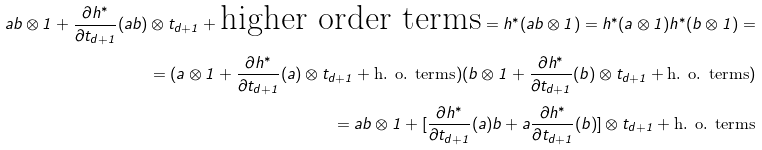<formula> <loc_0><loc_0><loc_500><loc_500>a b \otimes 1 + \frac { \partial h ^ { * } } { \partial t _ { d + 1 } } ( a b ) \otimes t _ { d + 1 } + \text {higher order terms} = h ^ { * } ( a b \otimes 1 ) = h ^ { * } ( a \otimes 1 ) h ^ { * } ( b \otimes 1 ) = \\ = ( a \otimes 1 + \frac { \partial h ^ { * } } { \partial t _ { d + 1 } } ( a ) \otimes t _ { d + 1 } + \text {h. o. terms} ) ( b \otimes 1 + \frac { \partial h ^ { * } } { \partial t _ { d + 1 } } ( b ) \otimes t _ { d + 1 } + \text {h. o. terms} ) \\ = a b \otimes 1 + [ \frac { \partial h ^ { * } } { \partial t _ { d + 1 } } ( a ) b + a \frac { \partial h ^ { * } } { \partial t _ { d + 1 } } ( b ) ] \otimes t _ { d + 1 } + \text {h. o. terms}</formula> 